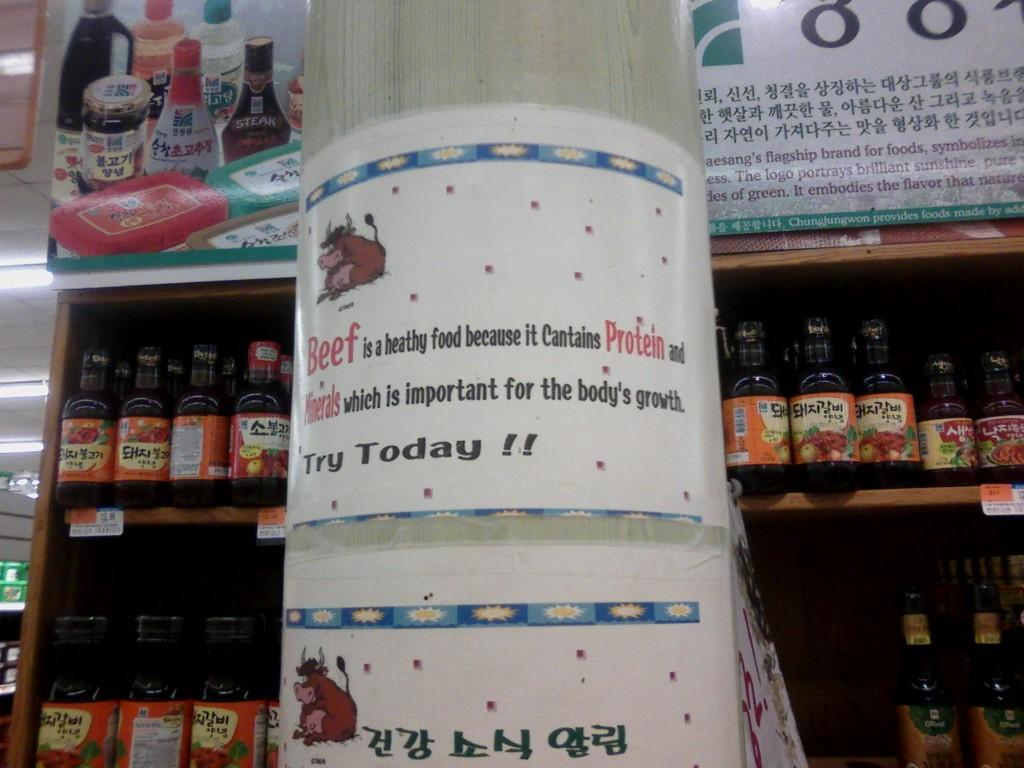<image>
Share a concise interpretation of the image provided. A flyer for beef encourages to try it today. 